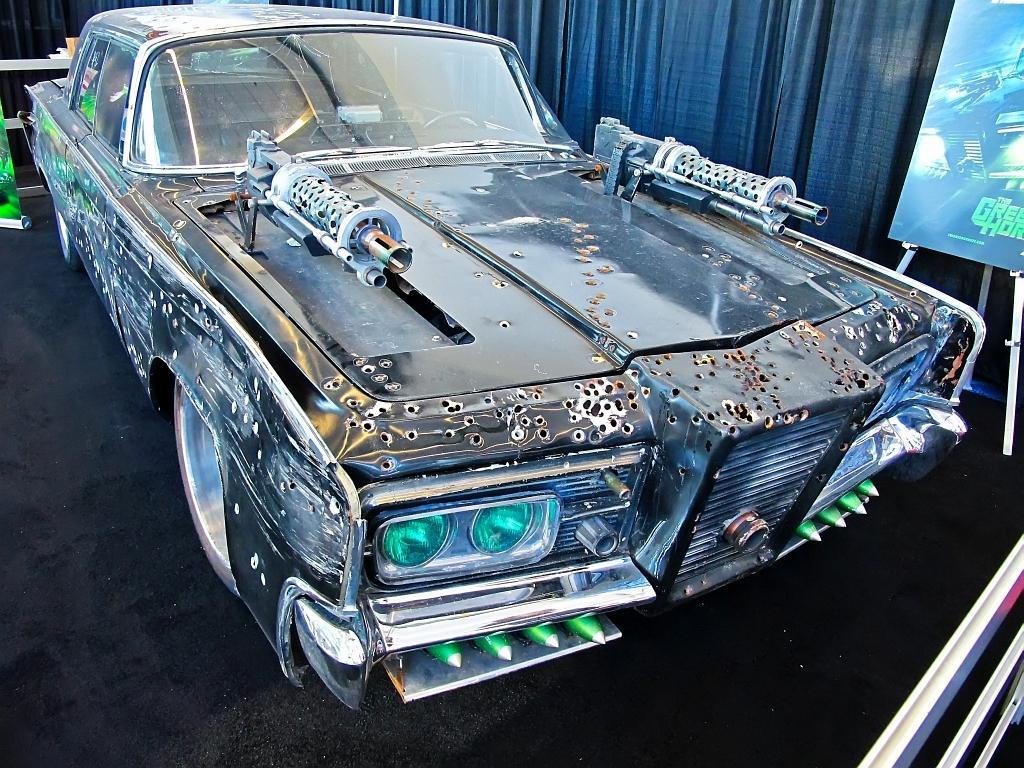What is the main subject of the image? The main subject of the image is a damaged car in the center of the image. What else can be seen in the image besides the damaged car? There is a poster on the right side of the image. What type of mark can be seen on the damaged car in the image? There is no specific mark mentioned in the facts provided, so it cannot be determined from the image. 